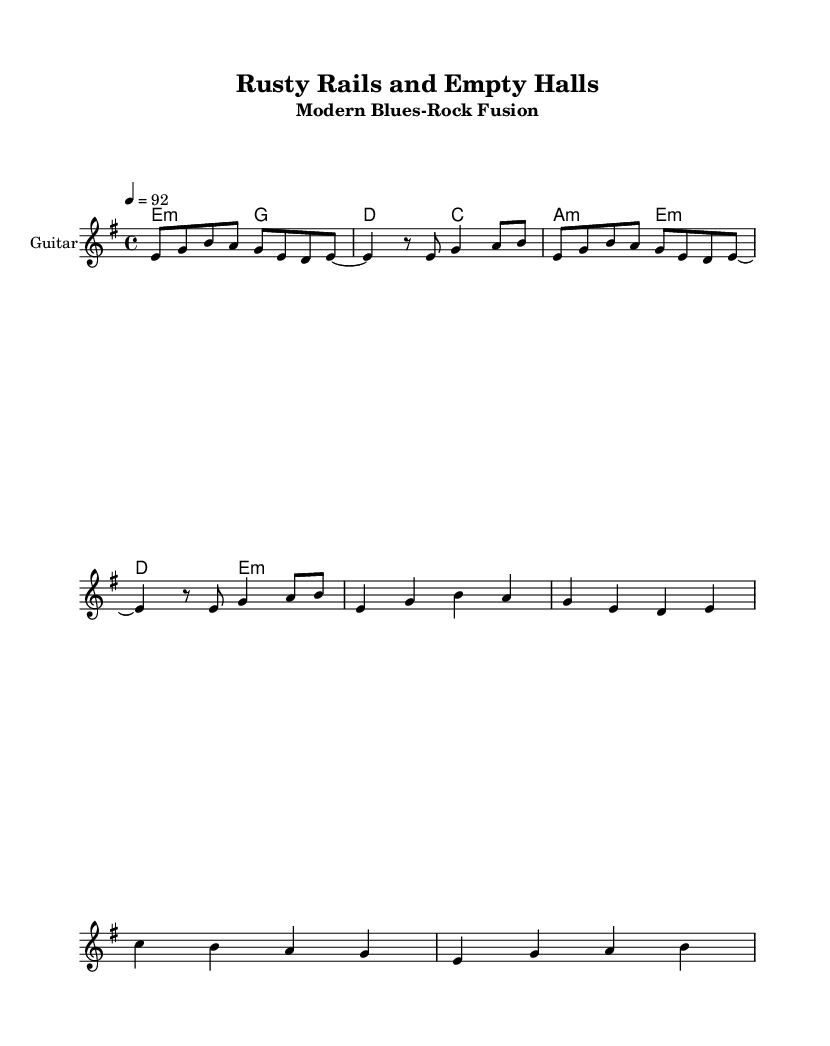What is the key signature of this music? The key signature is E minor, which contains one sharp (F#) as indicated at the beginning of the score.
Answer: E minor What is the time signature of this piece? The time signature is 4/4, which is indicated at the beginning of the score, meaning there are four beats in each measure.
Answer: 4/4 What is the tempo marking for this piece? The tempo marking is set at 92 beats per minute, as shown in the tempo indication within the score.
Answer: 92 How many measures are there in the chorus? To find this, we count the number of lines in the chorus section: there are two lines, each with four beats, equating to two measures.
Answer: 2 measures What is the first chord in the verse? The first chord in the verse section is E minor, which is located at the start of the chords that outline the verse.
Answer: E minor What emotion is conveyed in the lyrics about the railroad towns? The lyrics reflect a sense of nostalgia and loss, which can be inferred from phrases like "empty platforms" and "echoes of a bygone age."
Answer: Nostalgia How does the melody of the verse compare to the melody of the chorus? The melody of the verse is more subdued and reflective, while the chorus has a more uplifting and declarative character, demonstrated by the rise in pitch and intensity.
Answer: Uplifting 